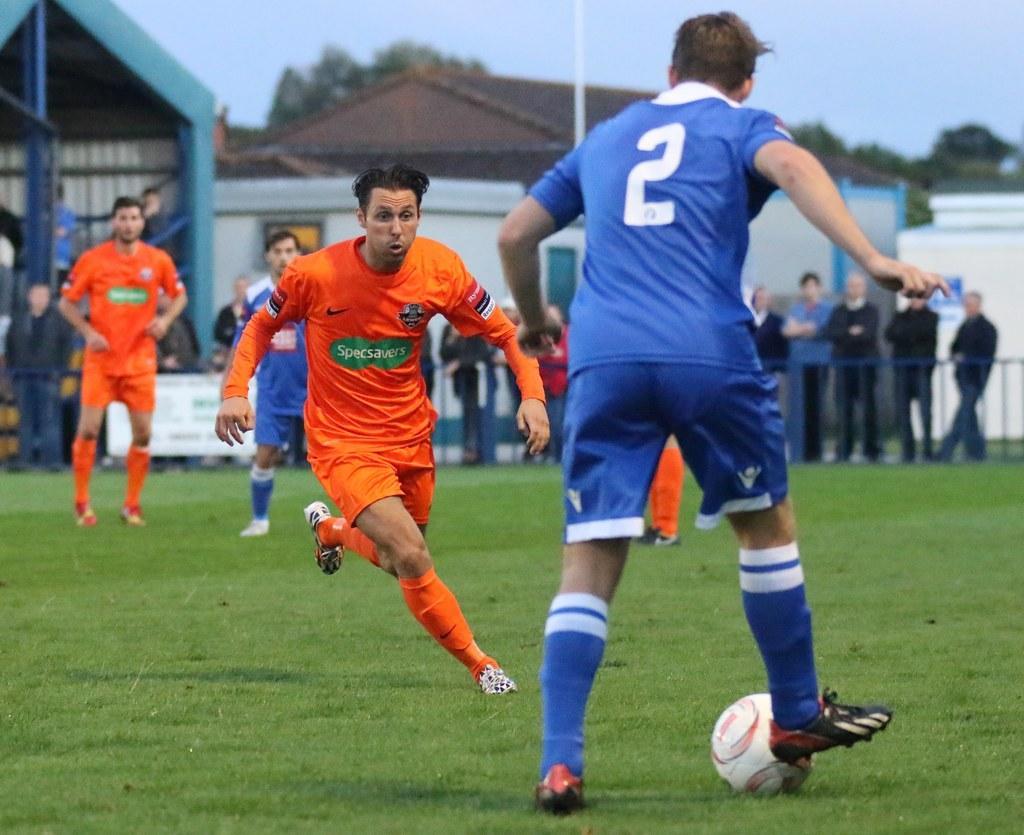How would you summarize this image in a sentence or two? This picture shows some people playing a football in the ground. Some of them were standing in the background and watching the game. There are some building, poles, trees and a sky here. 